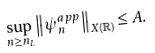<formula> <loc_0><loc_0><loc_500><loc_500>\sup _ { n \geq n _ { L } } \left \| \psi _ { n } ^ { a p p } \right \| _ { X ( \mathbb { R } ) } \leq A .</formula> 